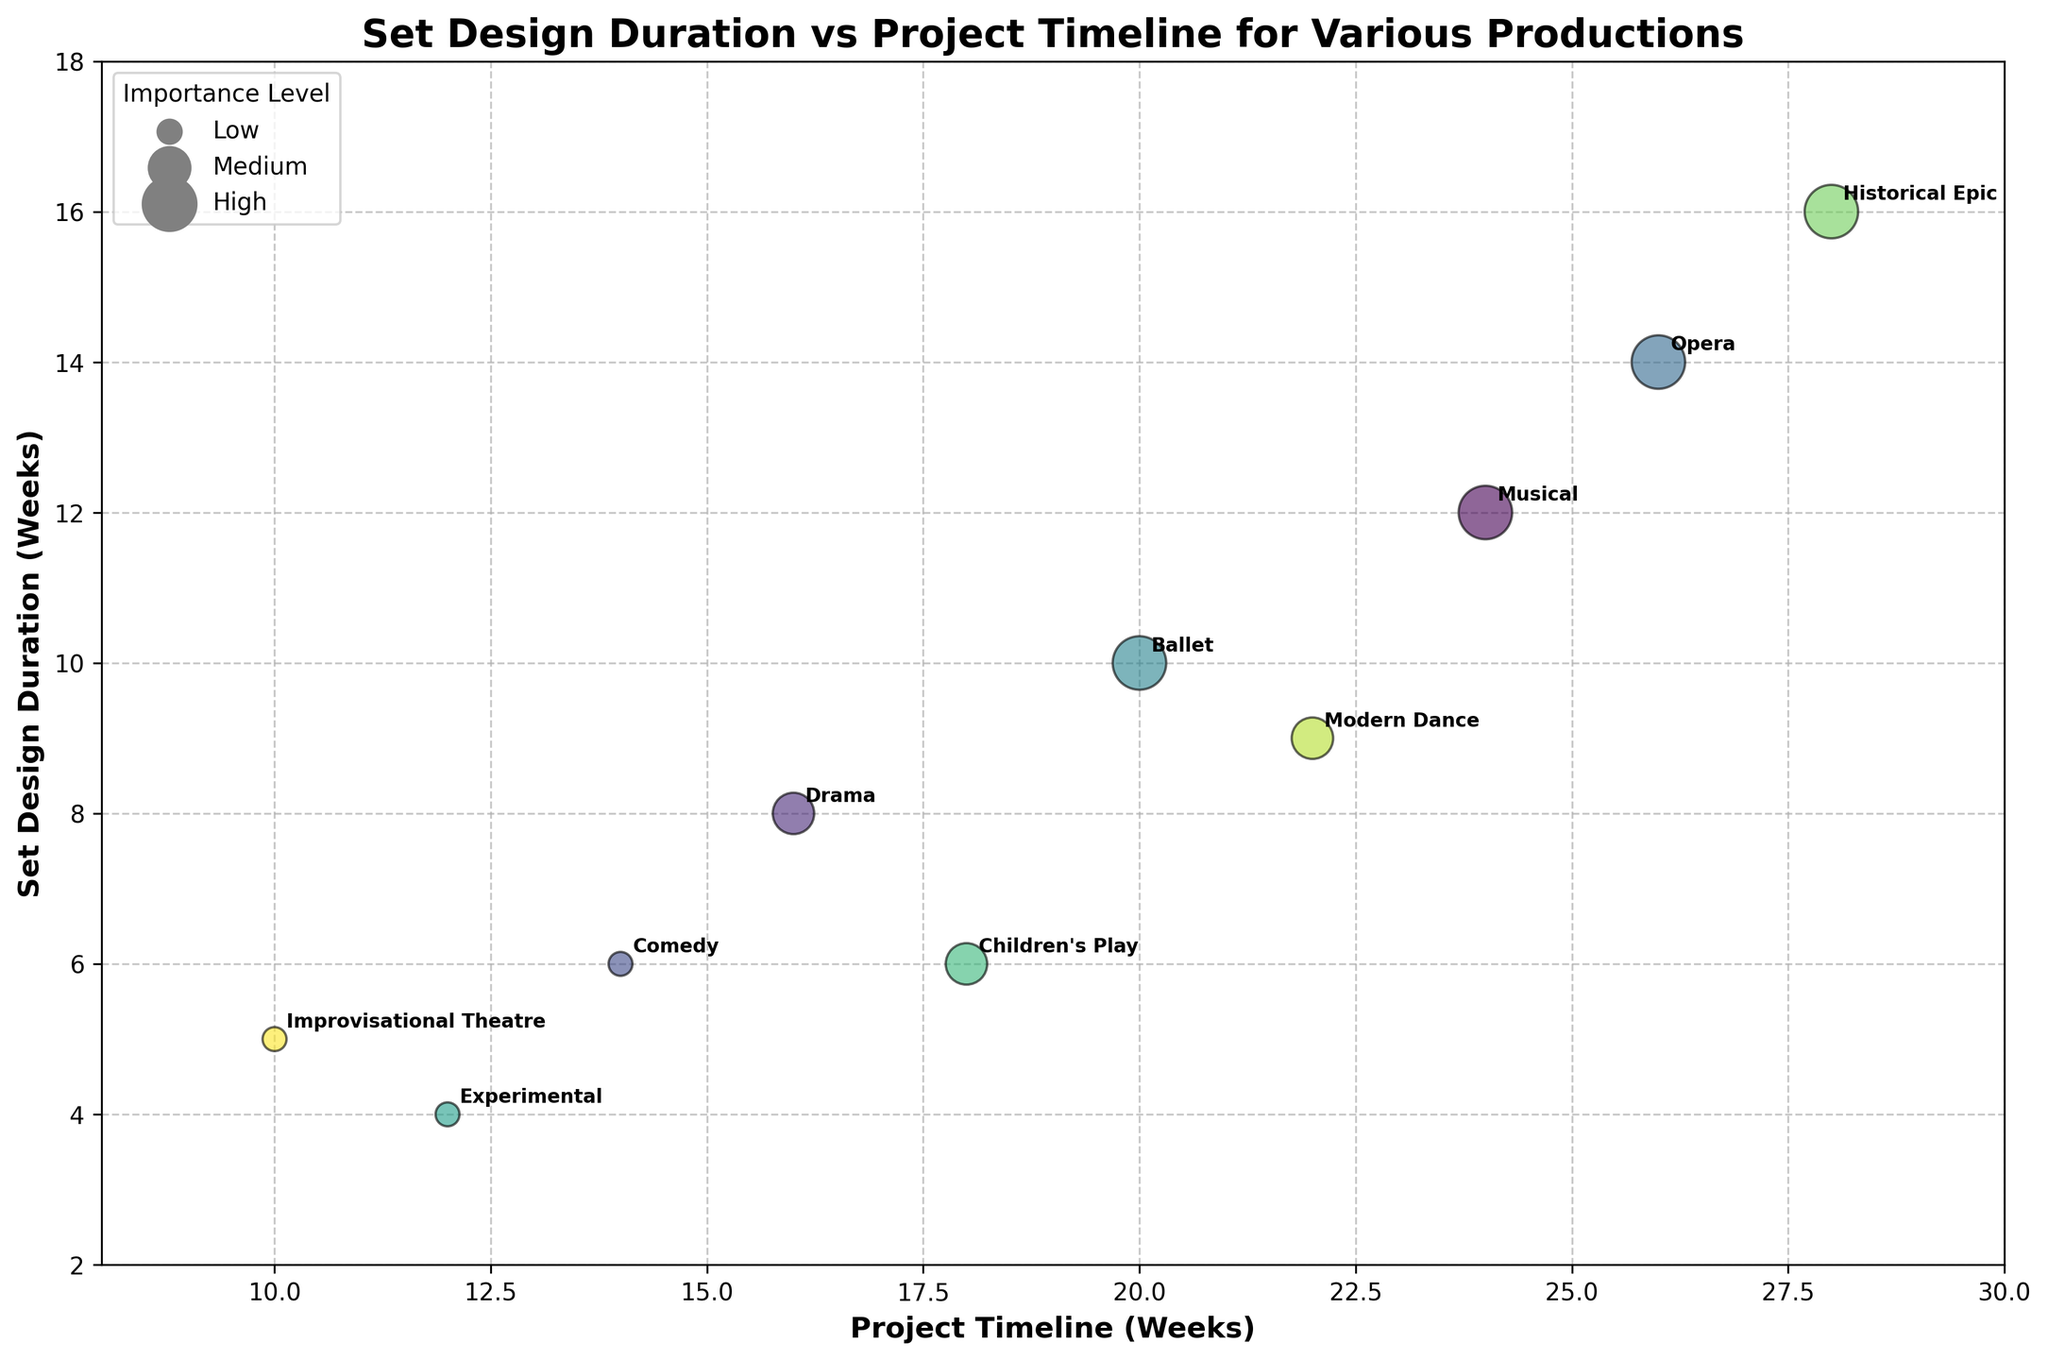What's the title of the figure? The title of the figure is displayed at the top of the plot, clearly indicating what the plot is about. It provides context to understand the data shown.
Answer: Set Design Duration vs Project Timeline for Various Productions What are the axis labels? The axis labels are shown on both the x-axis and y-axis. They provide information about the variables being plotted. The x-axis label is "Project Timeline (Weeks)" and the y-axis label is "Set Design Duration (Weeks)".
Answer: Project Timeline (Weeks) and Set Design Duration (Weeks) How many productions have a high importance level? By looking at the size of the bubbles corresponding to the "High" importance level (largest bubbles), we can count them.
Answer: 4 Which production type has the longest set design duration? We can find the longest set design duration by looking at the highest y-axis value and noting the associated production type label.
Answer: Historical Epic Which production has the shortest project timeline? We identify the shortest project timeline by looking at the smallest x-axis value and noting the associated production type label.
Answer: Improvisational Theatre Compare the set design duration of Ballet and Modern Dance. Which one is longer? By locating the points for Ballet and Modern Dance on the y-axis, we see that Ballet has a set design duration of 10 weeks, while Modern Dance has 9 weeks, so Ballet has a longer set design duration.
Answer: Ballet How does the project timeline for Drama compare with Children's Play? By comparing the x-axis values, Drama has a timeline of 16 weeks and Children's Play has 18 weeks. Drama has a shorter project timeline.
Answer: Drama What's the relationship between the size of the bubbles and the importance level of the productions? The size of the bubbles represents the importance level, with larger bubbles indicating a higher importance level. Low importance is represented by smaller bubbles, Medium by medium-sized bubbles, and High by the largest bubbles.
Answer: Larger bubbles indicate higher importance What is the average set design duration for High importance productions? First, identify the set design durations for High importance productions: 12, 14, 10, and 16 weeks. Add these together (12 + 14 + 10 + 16 = 52) and then divide by the number of High importance productions (52/4).
Answer: 13 weeks Which production shows an inconsistency between a relatively short set design duration and a long project timeline? By cross-referencing smaller y-axis values with larger x-axis values, Modern Dance stands out with a 9-week design duration and a 22-week project timeline.
Answer: Modern Dance 